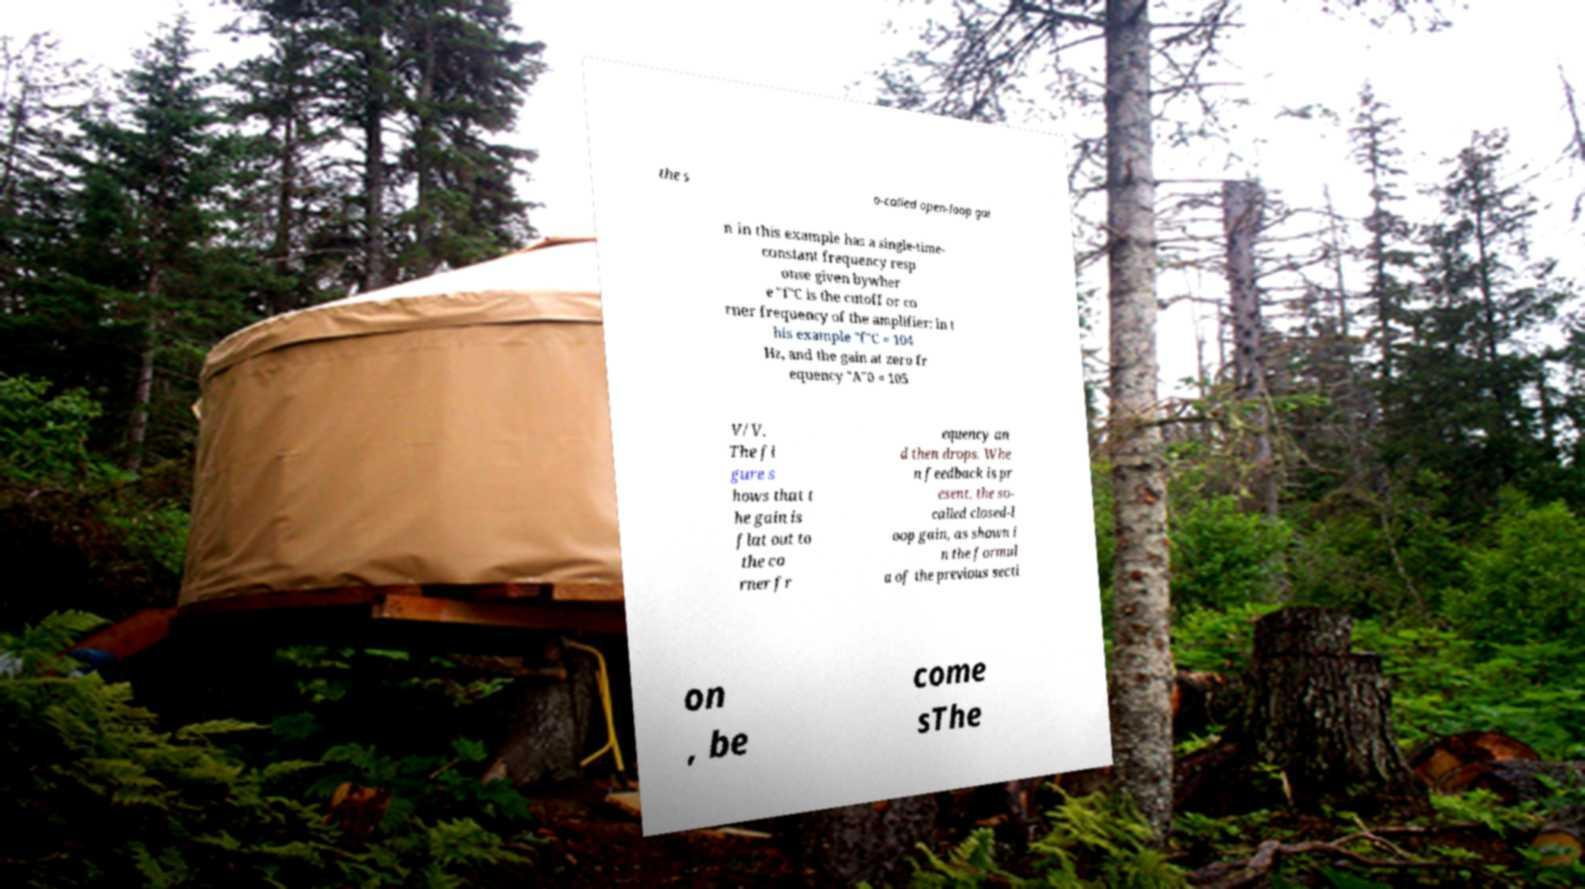I need the written content from this picture converted into text. Can you do that? the s o-called open-loop gai n in this example has a single-time- constant frequency resp onse given bywher e "f"C is the cutoff or co rner frequency of the amplifier: in t his example "f"C = 104 Hz, and the gain at zero fr equency "A"0 = 105 V/V. The fi gure s hows that t he gain is flat out to the co rner fr equency an d then drops. Whe n feedback is pr esent, the so- called closed-l oop gain, as shown i n the formul a of the previous secti on , be come sThe 